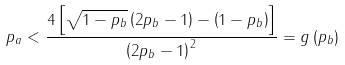Convert formula to latex. <formula><loc_0><loc_0><loc_500><loc_500>p _ { a } < \frac { 4 \left [ \sqrt { 1 - p _ { b } } \left ( 2 p _ { b } - 1 \right ) - \left ( 1 - p _ { b } \right ) \right ] } { \left ( 2 p _ { b } - 1 \right ) ^ { 2 } } = g \left ( p _ { b } \right )</formula> 